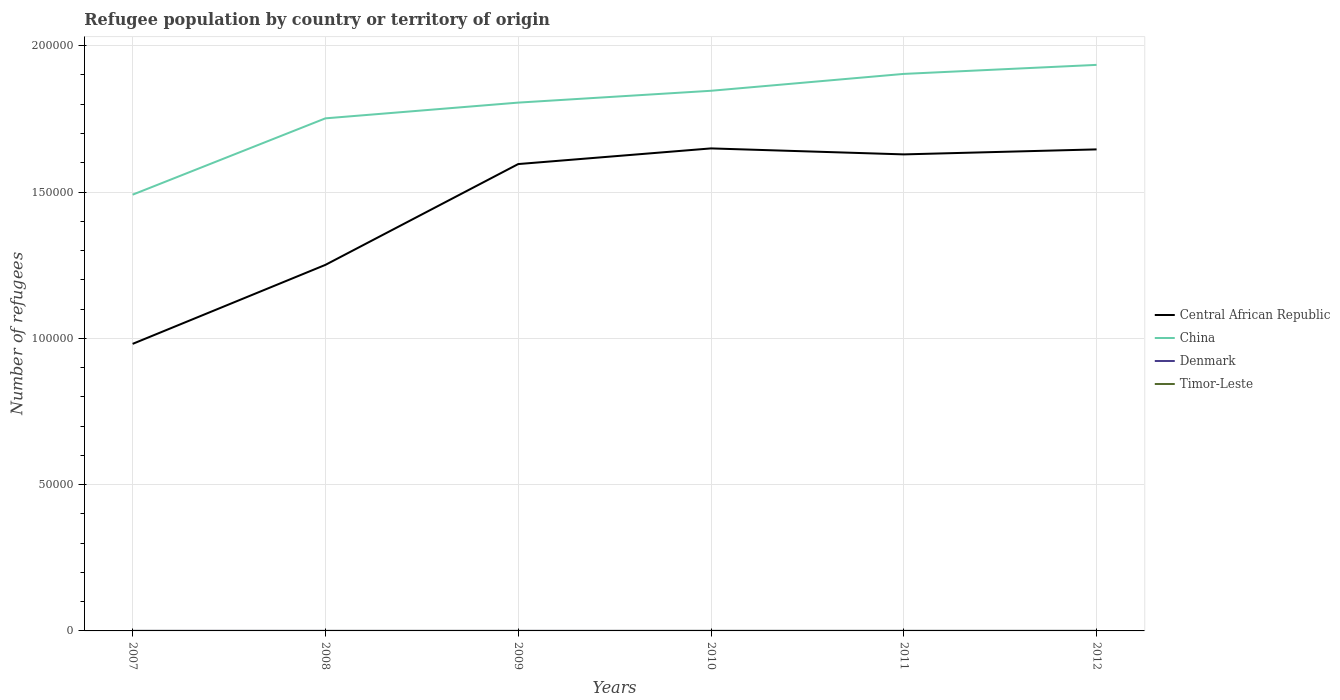How many different coloured lines are there?
Provide a succinct answer. 4. Is the number of lines equal to the number of legend labels?
Provide a succinct answer. Yes. Across all years, what is the maximum number of refugees in China?
Your answer should be very brief. 1.49e+05. In which year was the number of refugees in Central African Republic maximum?
Provide a short and direct response. 2007. What is the total number of refugees in Central African Republic in the graph?
Offer a very short reply. -5014. What is the difference between the highest and the second highest number of refugees in Timor-Leste?
Offer a terse response. 3. How many lines are there?
Provide a succinct answer. 4. How many years are there in the graph?
Your response must be concise. 6. What is the difference between two consecutive major ticks on the Y-axis?
Your response must be concise. 5.00e+04. Are the values on the major ticks of Y-axis written in scientific E-notation?
Your response must be concise. No. Where does the legend appear in the graph?
Ensure brevity in your answer.  Center right. What is the title of the graph?
Offer a terse response. Refugee population by country or territory of origin. What is the label or title of the Y-axis?
Offer a terse response. Number of refugees. What is the Number of refugees of Central African Republic in 2007?
Provide a succinct answer. 9.81e+04. What is the Number of refugees in China in 2007?
Ensure brevity in your answer.  1.49e+05. What is the Number of refugees of Timor-Leste in 2007?
Offer a terse response. 6. What is the Number of refugees in Central African Republic in 2008?
Ensure brevity in your answer.  1.25e+05. What is the Number of refugees of China in 2008?
Provide a short and direct response. 1.75e+05. What is the Number of refugees of Central African Republic in 2009?
Provide a short and direct response. 1.60e+05. What is the Number of refugees in China in 2009?
Provide a short and direct response. 1.81e+05. What is the Number of refugees of Central African Republic in 2010?
Ensure brevity in your answer.  1.65e+05. What is the Number of refugees in China in 2010?
Keep it short and to the point. 1.85e+05. What is the Number of refugees in Timor-Leste in 2010?
Your response must be concise. 8. What is the Number of refugees in Central African Republic in 2011?
Your response must be concise. 1.63e+05. What is the Number of refugees of China in 2011?
Keep it short and to the point. 1.90e+05. What is the Number of refugees of Timor-Leste in 2011?
Your answer should be very brief. 8. What is the Number of refugees in Central African Republic in 2012?
Make the answer very short. 1.65e+05. What is the Number of refugees in China in 2012?
Your answer should be compact. 1.93e+05. What is the Number of refugees in Denmark in 2012?
Give a very brief answer. 9. What is the Number of refugees in Timor-Leste in 2012?
Offer a very short reply. 9. Across all years, what is the maximum Number of refugees in Central African Republic?
Give a very brief answer. 1.65e+05. Across all years, what is the maximum Number of refugees of China?
Your answer should be compact. 1.93e+05. Across all years, what is the maximum Number of refugees in Denmark?
Provide a short and direct response. 14. Across all years, what is the minimum Number of refugees of Central African Republic?
Your response must be concise. 9.81e+04. Across all years, what is the minimum Number of refugees of China?
Your answer should be compact. 1.49e+05. Across all years, what is the minimum Number of refugees in Denmark?
Provide a succinct answer. 9. Across all years, what is the minimum Number of refugees of Timor-Leste?
Your answer should be compact. 6. What is the total Number of refugees of Central African Republic in the graph?
Your response must be concise. 8.75e+05. What is the total Number of refugees in China in the graph?
Give a very brief answer. 1.07e+06. What is the total Number of refugees of Denmark in the graph?
Make the answer very short. 62. What is the difference between the Number of refugees in Central African Republic in 2007 and that in 2008?
Your answer should be very brief. -2.70e+04. What is the difference between the Number of refugees in China in 2007 and that in 2008?
Your response must be concise. -2.61e+04. What is the difference between the Number of refugees of Central African Republic in 2007 and that in 2009?
Your answer should be very brief. -6.14e+04. What is the difference between the Number of refugees in China in 2007 and that in 2009?
Your response must be concise. -3.15e+04. What is the difference between the Number of refugees in Timor-Leste in 2007 and that in 2009?
Provide a succinct answer. -1. What is the difference between the Number of refugees of Central African Republic in 2007 and that in 2010?
Your answer should be very brief. -6.68e+04. What is the difference between the Number of refugees in China in 2007 and that in 2010?
Offer a very short reply. -3.55e+04. What is the difference between the Number of refugees of Denmark in 2007 and that in 2010?
Offer a very short reply. 5. What is the difference between the Number of refugees of Central African Republic in 2007 and that in 2011?
Give a very brief answer. -6.48e+04. What is the difference between the Number of refugees of China in 2007 and that in 2011?
Your response must be concise. -4.13e+04. What is the difference between the Number of refugees of Denmark in 2007 and that in 2011?
Offer a terse response. 5. What is the difference between the Number of refugees in Central African Republic in 2007 and that in 2012?
Provide a short and direct response. -6.65e+04. What is the difference between the Number of refugees in China in 2007 and that in 2012?
Your answer should be compact. -4.44e+04. What is the difference between the Number of refugees in Central African Republic in 2008 and that in 2009?
Your answer should be compact. -3.44e+04. What is the difference between the Number of refugees of China in 2008 and that in 2009?
Provide a short and direct response. -5378. What is the difference between the Number of refugees of Central African Republic in 2008 and that in 2010?
Your response must be concise. -3.98e+04. What is the difference between the Number of refugees of China in 2008 and that in 2010?
Your answer should be very brief. -9422. What is the difference between the Number of refugees of Denmark in 2008 and that in 2010?
Give a very brief answer. 2. What is the difference between the Number of refugees of Central African Republic in 2008 and that in 2011?
Give a very brief answer. -3.78e+04. What is the difference between the Number of refugees in China in 2008 and that in 2011?
Your response must be concise. -1.52e+04. What is the difference between the Number of refugees of Timor-Leste in 2008 and that in 2011?
Offer a very short reply. -1. What is the difference between the Number of refugees of Central African Republic in 2008 and that in 2012?
Offer a terse response. -3.95e+04. What is the difference between the Number of refugees in China in 2008 and that in 2012?
Your answer should be very brief. -1.83e+04. What is the difference between the Number of refugees in Timor-Leste in 2008 and that in 2012?
Offer a very short reply. -2. What is the difference between the Number of refugees of Central African Republic in 2009 and that in 2010?
Offer a terse response. -5351. What is the difference between the Number of refugees in China in 2009 and that in 2010?
Provide a short and direct response. -4044. What is the difference between the Number of refugees of Denmark in 2009 and that in 2010?
Keep it short and to the point. 1. What is the difference between the Number of refugees in Timor-Leste in 2009 and that in 2010?
Your response must be concise. -1. What is the difference between the Number of refugees in Central African Republic in 2009 and that in 2011?
Ensure brevity in your answer.  -3308. What is the difference between the Number of refugees of China in 2009 and that in 2011?
Your answer should be compact. -9811. What is the difference between the Number of refugees of Timor-Leste in 2009 and that in 2011?
Your answer should be compact. -1. What is the difference between the Number of refugees of Central African Republic in 2009 and that in 2012?
Offer a terse response. -5014. What is the difference between the Number of refugees of China in 2009 and that in 2012?
Provide a short and direct response. -1.29e+04. What is the difference between the Number of refugees of Denmark in 2009 and that in 2012?
Your response must be concise. 1. What is the difference between the Number of refugees in Central African Republic in 2010 and that in 2011?
Provide a short and direct response. 2043. What is the difference between the Number of refugees in China in 2010 and that in 2011?
Provide a short and direct response. -5767. What is the difference between the Number of refugees in Denmark in 2010 and that in 2011?
Your response must be concise. 0. What is the difference between the Number of refugees of Central African Republic in 2010 and that in 2012?
Offer a terse response. 337. What is the difference between the Number of refugees in China in 2010 and that in 2012?
Your answer should be very brief. -8851. What is the difference between the Number of refugees of Timor-Leste in 2010 and that in 2012?
Keep it short and to the point. -1. What is the difference between the Number of refugees of Central African Republic in 2011 and that in 2012?
Give a very brief answer. -1706. What is the difference between the Number of refugees in China in 2011 and that in 2012?
Ensure brevity in your answer.  -3084. What is the difference between the Number of refugees in Timor-Leste in 2011 and that in 2012?
Offer a very short reply. -1. What is the difference between the Number of refugees in Central African Republic in 2007 and the Number of refugees in China in 2008?
Ensure brevity in your answer.  -7.71e+04. What is the difference between the Number of refugees in Central African Republic in 2007 and the Number of refugees in Denmark in 2008?
Offer a terse response. 9.81e+04. What is the difference between the Number of refugees in Central African Republic in 2007 and the Number of refugees in Timor-Leste in 2008?
Ensure brevity in your answer.  9.81e+04. What is the difference between the Number of refugees in China in 2007 and the Number of refugees in Denmark in 2008?
Offer a very short reply. 1.49e+05. What is the difference between the Number of refugees of China in 2007 and the Number of refugees of Timor-Leste in 2008?
Your answer should be very brief. 1.49e+05. What is the difference between the Number of refugees in Denmark in 2007 and the Number of refugees in Timor-Leste in 2008?
Offer a very short reply. 7. What is the difference between the Number of refugees in Central African Republic in 2007 and the Number of refugees in China in 2009?
Keep it short and to the point. -8.25e+04. What is the difference between the Number of refugees of Central African Republic in 2007 and the Number of refugees of Denmark in 2009?
Ensure brevity in your answer.  9.81e+04. What is the difference between the Number of refugees of Central African Republic in 2007 and the Number of refugees of Timor-Leste in 2009?
Provide a short and direct response. 9.81e+04. What is the difference between the Number of refugees in China in 2007 and the Number of refugees in Denmark in 2009?
Keep it short and to the point. 1.49e+05. What is the difference between the Number of refugees in China in 2007 and the Number of refugees in Timor-Leste in 2009?
Offer a very short reply. 1.49e+05. What is the difference between the Number of refugees in Central African Republic in 2007 and the Number of refugees in China in 2010?
Provide a succinct answer. -8.65e+04. What is the difference between the Number of refugees of Central African Republic in 2007 and the Number of refugees of Denmark in 2010?
Give a very brief answer. 9.81e+04. What is the difference between the Number of refugees in Central African Republic in 2007 and the Number of refugees in Timor-Leste in 2010?
Provide a short and direct response. 9.81e+04. What is the difference between the Number of refugees of China in 2007 and the Number of refugees of Denmark in 2010?
Offer a very short reply. 1.49e+05. What is the difference between the Number of refugees of China in 2007 and the Number of refugees of Timor-Leste in 2010?
Offer a very short reply. 1.49e+05. What is the difference between the Number of refugees in Denmark in 2007 and the Number of refugees in Timor-Leste in 2010?
Ensure brevity in your answer.  6. What is the difference between the Number of refugees in Central African Republic in 2007 and the Number of refugees in China in 2011?
Provide a short and direct response. -9.23e+04. What is the difference between the Number of refugees of Central African Republic in 2007 and the Number of refugees of Denmark in 2011?
Provide a short and direct response. 9.81e+04. What is the difference between the Number of refugees of Central African Republic in 2007 and the Number of refugees of Timor-Leste in 2011?
Keep it short and to the point. 9.81e+04. What is the difference between the Number of refugees in China in 2007 and the Number of refugees in Denmark in 2011?
Your answer should be very brief. 1.49e+05. What is the difference between the Number of refugees of China in 2007 and the Number of refugees of Timor-Leste in 2011?
Ensure brevity in your answer.  1.49e+05. What is the difference between the Number of refugees in Denmark in 2007 and the Number of refugees in Timor-Leste in 2011?
Provide a succinct answer. 6. What is the difference between the Number of refugees in Central African Republic in 2007 and the Number of refugees in China in 2012?
Provide a succinct answer. -9.53e+04. What is the difference between the Number of refugees in Central African Republic in 2007 and the Number of refugees in Denmark in 2012?
Provide a short and direct response. 9.81e+04. What is the difference between the Number of refugees of Central African Republic in 2007 and the Number of refugees of Timor-Leste in 2012?
Offer a terse response. 9.81e+04. What is the difference between the Number of refugees of China in 2007 and the Number of refugees of Denmark in 2012?
Ensure brevity in your answer.  1.49e+05. What is the difference between the Number of refugees of China in 2007 and the Number of refugees of Timor-Leste in 2012?
Offer a very short reply. 1.49e+05. What is the difference between the Number of refugees in Central African Republic in 2008 and the Number of refugees in China in 2009?
Keep it short and to the point. -5.55e+04. What is the difference between the Number of refugees in Central African Republic in 2008 and the Number of refugees in Denmark in 2009?
Provide a succinct answer. 1.25e+05. What is the difference between the Number of refugees in Central African Republic in 2008 and the Number of refugees in Timor-Leste in 2009?
Keep it short and to the point. 1.25e+05. What is the difference between the Number of refugees of China in 2008 and the Number of refugees of Denmark in 2009?
Offer a terse response. 1.75e+05. What is the difference between the Number of refugees of China in 2008 and the Number of refugees of Timor-Leste in 2009?
Ensure brevity in your answer.  1.75e+05. What is the difference between the Number of refugees of Denmark in 2008 and the Number of refugees of Timor-Leste in 2009?
Your answer should be compact. 4. What is the difference between the Number of refugees in Central African Republic in 2008 and the Number of refugees in China in 2010?
Make the answer very short. -5.95e+04. What is the difference between the Number of refugees in Central African Republic in 2008 and the Number of refugees in Denmark in 2010?
Keep it short and to the point. 1.25e+05. What is the difference between the Number of refugees in Central African Republic in 2008 and the Number of refugees in Timor-Leste in 2010?
Provide a short and direct response. 1.25e+05. What is the difference between the Number of refugees of China in 2008 and the Number of refugees of Denmark in 2010?
Offer a very short reply. 1.75e+05. What is the difference between the Number of refugees of China in 2008 and the Number of refugees of Timor-Leste in 2010?
Provide a short and direct response. 1.75e+05. What is the difference between the Number of refugees in Central African Republic in 2008 and the Number of refugees in China in 2011?
Offer a terse response. -6.53e+04. What is the difference between the Number of refugees of Central African Republic in 2008 and the Number of refugees of Denmark in 2011?
Make the answer very short. 1.25e+05. What is the difference between the Number of refugees in Central African Republic in 2008 and the Number of refugees in Timor-Leste in 2011?
Your response must be concise. 1.25e+05. What is the difference between the Number of refugees in China in 2008 and the Number of refugees in Denmark in 2011?
Keep it short and to the point. 1.75e+05. What is the difference between the Number of refugees of China in 2008 and the Number of refugees of Timor-Leste in 2011?
Your answer should be compact. 1.75e+05. What is the difference between the Number of refugees in Denmark in 2008 and the Number of refugees in Timor-Leste in 2011?
Give a very brief answer. 3. What is the difference between the Number of refugees of Central African Republic in 2008 and the Number of refugees of China in 2012?
Ensure brevity in your answer.  -6.83e+04. What is the difference between the Number of refugees of Central African Republic in 2008 and the Number of refugees of Denmark in 2012?
Provide a succinct answer. 1.25e+05. What is the difference between the Number of refugees in Central African Republic in 2008 and the Number of refugees in Timor-Leste in 2012?
Ensure brevity in your answer.  1.25e+05. What is the difference between the Number of refugees of China in 2008 and the Number of refugees of Denmark in 2012?
Your answer should be compact. 1.75e+05. What is the difference between the Number of refugees in China in 2008 and the Number of refugees in Timor-Leste in 2012?
Give a very brief answer. 1.75e+05. What is the difference between the Number of refugees in Central African Republic in 2009 and the Number of refugees in China in 2010?
Provide a succinct answer. -2.50e+04. What is the difference between the Number of refugees of Central African Republic in 2009 and the Number of refugees of Denmark in 2010?
Your answer should be compact. 1.60e+05. What is the difference between the Number of refugees in Central African Republic in 2009 and the Number of refugees in Timor-Leste in 2010?
Make the answer very short. 1.60e+05. What is the difference between the Number of refugees of China in 2009 and the Number of refugees of Denmark in 2010?
Offer a very short reply. 1.81e+05. What is the difference between the Number of refugees in China in 2009 and the Number of refugees in Timor-Leste in 2010?
Ensure brevity in your answer.  1.81e+05. What is the difference between the Number of refugees in Denmark in 2009 and the Number of refugees in Timor-Leste in 2010?
Provide a short and direct response. 2. What is the difference between the Number of refugees of Central African Republic in 2009 and the Number of refugees of China in 2011?
Your answer should be very brief. -3.08e+04. What is the difference between the Number of refugees of Central African Republic in 2009 and the Number of refugees of Denmark in 2011?
Keep it short and to the point. 1.60e+05. What is the difference between the Number of refugees of Central African Republic in 2009 and the Number of refugees of Timor-Leste in 2011?
Provide a short and direct response. 1.60e+05. What is the difference between the Number of refugees of China in 2009 and the Number of refugees of Denmark in 2011?
Your response must be concise. 1.81e+05. What is the difference between the Number of refugees of China in 2009 and the Number of refugees of Timor-Leste in 2011?
Provide a short and direct response. 1.81e+05. What is the difference between the Number of refugees in Central African Republic in 2009 and the Number of refugees in China in 2012?
Keep it short and to the point. -3.39e+04. What is the difference between the Number of refugees of Central African Republic in 2009 and the Number of refugees of Denmark in 2012?
Your answer should be compact. 1.60e+05. What is the difference between the Number of refugees in Central African Republic in 2009 and the Number of refugees in Timor-Leste in 2012?
Give a very brief answer. 1.60e+05. What is the difference between the Number of refugees of China in 2009 and the Number of refugees of Denmark in 2012?
Offer a terse response. 1.81e+05. What is the difference between the Number of refugees of China in 2009 and the Number of refugees of Timor-Leste in 2012?
Give a very brief answer. 1.81e+05. What is the difference between the Number of refugees in Denmark in 2009 and the Number of refugees in Timor-Leste in 2012?
Give a very brief answer. 1. What is the difference between the Number of refugees of Central African Republic in 2010 and the Number of refugees of China in 2011?
Offer a terse response. -2.55e+04. What is the difference between the Number of refugees of Central African Republic in 2010 and the Number of refugees of Denmark in 2011?
Provide a succinct answer. 1.65e+05. What is the difference between the Number of refugees in Central African Republic in 2010 and the Number of refugees in Timor-Leste in 2011?
Make the answer very short. 1.65e+05. What is the difference between the Number of refugees of China in 2010 and the Number of refugees of Denmark in 2011?
Offer a terse response. 1.85e+05. What is the difference between the Number of refugees of China in 2010 and the Number of refugees of Timor-Leste in 2011?
Give a very brief answer. 1.85e+05. What is the difference between the Number of refugees of Central African Republic in 2010 and the Number of refugees of China in 2012?
Provide a short and direct response. -2.85e+04. What is the difference between the Number of refugees in Central African Republic in 2010 and the Number of refugees in Denmark in 2012?
Offer a terse response. 1.65e+05. What is the difference between the Number of refugees of Central African Republic in 2010 and the Number of refugees of Timor-Leste in 2012?
Your answer should be very brief. 1.65e+05. What is the difference between the Number of refugees of China in 2010 and the Number of refugees of Denmark in 2012?
Make the answer very short. 1.85e+05. What is the difference between the Number of refugees of China in 2010 and the Number of refugees of Timor-Leste in 2012?
Offer a very short reply. 1.85e+05. What is the difference between the Number of refugees of Denmark in 2010 and the Number of refugees of Timor-Leste in 2012?
Make the answer very short. 0. What is the difference between the Number of refugees of Central African Republic in 2011 and the Number of refugees of China in 2012?
Ensure brevity in your answer.  -3.06e+04. What is the difference between the Number of refugees in Central African Republic in 2011 and the Number of refugees in Denmark in 2012?
Ensure brevity in your answer.  1.63e+05. What is the difference between the Number of refugees in Central African Republic in 2011 and the Number of refugees in Timor-Leste in 2012?
Keep it short and to the point. 1.63e+05. What is the difference between the Number of refugees of China in 2011 and the Number of refugees of Denmark in 2012?
Keep it short and to the point. 1.90e+05. What is the difference between the Number of refugees in China in 2011 and the Number of refugees in Timor-Leste in 2012?
Ensure brevity in your answer.  1.90e+05. What is the difference between the Number of refugees in Denmark in 2011 and the Number of refugees in Timor-Leste in 2012?
Your answer should be compact. 0. What is the average Number of refugees of Central African Republic per year?
Make the answer very short. 1.46e+05. What is the average Number of refugees of China per year?
Your answer should be very brief. 1.79e+05. What is the average Number of refugees of Denmark per year?
Provide a short and direct response. 10.33. What is the average Number of refugees of Timor-Leste per year?
Provide a short and direct response. 7.5. In the year 2007, what is the difference between the Number of refugees in Central African Republic and Number of refugees in China?
Your answer should be compact. -5.10e+04. In the year 2007, what is the difference between the Number of refugees in Central African Republic and Number of refugees in Denmark?
Provide a succinct answer. 9.81e+04. In the year 2007, what is the difference between the Number of refugees of Central African Republic and Number of refugees of Timor-Leste?
Offer a terse response. 9.81e+04. In the year 2007, what is the difference between the Number of refugees of China and Number of refugees of Denmark?
Offer a terse response. 1.49e+05. In the year 2007, what is the difference between the Number of refugees in China and Number of refugees in Timor-Leste?
Provide a succinct answer. 1.49e+05. In the year 2007, what is the difference between the Number of refugees of Denmark and Number of refugees of Timor-Leste?
Your answer should be compact. 8. In the year 2008, what is the difference between the Number of refugees of Central African Republic and Number of refugees of China?
Offer a very short reply. -5.01e+04. In the year 2008, what is the difference between the Number of refugees of Central African Republic and Number of refugees of Denmark?
Make the answer very short. 1.25e+05. In the year 2008, what is the difference between the Number of refugees of Central African Republic and Number of refugees of Timor-Leste?
Give a very brief answer. 1.25e+05. In the year 2008, what is the difference between the Number of refugees of China and Number of refugees of Denmark?
Offer a terse response. 1.75e+05. In the year 2008, what is the difference between the Number of refugees of China and Number of refugees of Timor-Leste?
Your answer should be compact. 1.75e+05. In the year 2009, what is the difference between the Number of refugees of Central African Republic and Number of refugees of China?
Keep it short and to the point. -2.10e+04. In the year 2009, what is the difference between the Number of refugees of Central African Republic and Number of refugees of Denmark?
Make the answer very short. 1.60e+05. In the year 2009, what is the difference between the Number of refugees of Central African Republic and Number of refugees of Timor-Leste?
Your answer should be very brief. 1.60e+05. In the year 2009, what is the difference between the Number of refugees of China and Number of refugees of Denmark?
Keep it short and to the point. 1.81e+05. In the year 2009, what is the difference between the Number of refugees in China and Number of refugees in Timor-Leste?
Your answer should be compact. 1.81e+05. In the year 2010, what is the difference between the Number of refugees of Central African Republic and Number of refugees of China?
Give a very brief answer. -1.97e+04. In the year 2010, what is the difference between the Number of refugees of Central African Republic and Number of refugees of Denmark?
Keep it short and to the point. 1.65e+05. In the year 2010, what is the difference between the Number of refugees of Central African Republic and Number of refugees of Timor-Leste?
Your answer should be compact. 1.65e+05. In the year 2010, what is the difference between the Number of refugees of China and Number of refugees of Denmark?
Provide a succinct answer. 1.85e+05. In the year 2010, what is the difference between the Number of refugees of China and Number of refugees of Timor-Leste?
Provide a succinct answer. 1.85e+05. In the year 2010, what is the difference between the Number of refugees in Denmark and Number of refugees in Timor-Leste?
Ensure brevity in your answer.  1. In the year 2011, what is the difference between the Number of refugees of Central African Republic and Number of refugees of China?
Keep it short and to the point. -2.75e+04. In the year 2011, what is the difference between the Number of refugees of Central African Republic and Number of refugees of Denmark?
Your answer should be very brief. 1.63e+05. In the year 2011, what is the difference between the Number of refugees in Central African Republic and Number of refugees in Timor-Leste?
Give a very brief answer. 1.63e+05. In the year 2011, what is the difference between the Number of refugees of China and Number of refugees of Denmark?
Offer a very short reply. 1.90e+05. In the year 2011, what is the difference between the Number of refugees in China and Number of refugees in Timor-Leste?
Offer a very short reply. 1.90e+05. In the year 2011, what is the difference between the Number of refugees of Denmark and Number of refugees of Timor-Leste?
Provide a short and direct response. 1. In the year 2012, what is the difference between the Number of refugees of Central African Republic and Number of refugees of China?
Your response must be concise. -2.89e+04. In the year 2012, what is the difference between the Number of refugees in Central African Republic and Number of refugees in Denmark?
Give a very brief answer. 1.65e+05. In the year 2012, what is the difference between the Number of refugees in Central African Republic and Number of refugees in Timor-Leste?
Keep it short and to the point. 1.65e+05. In the year 2012, what is the difference between the Number of refugees in China and Number of refugees in Denmark?
Provide a short and direct response. 1.93e+05. In the year 2012, what is the difference between the Number of refugees in China and Number of refugees in Timor-Leste?
Your response must be concise. 1.93e+05. What is the ratio of the Number of refugees of Central African Republic in 2007 to that in 2008?
Offer a very short reply. 0.78. What is the ratio of the Number of refugees in China in 2007 to that in 2008?
Your answer should be very brief. 0.85. What is the ratio of the Number of refugees of Denmark in 2007 to that in 2008?
Offer a terse response. 1.27. What is the ratio of the Number of refugees in Timor-Leste in 2007 to that in 2008?
Ensure brevity in your answer.  0.86. What is the ratio of the Number of refugees in Central African Republic in 2007 to that in 2009?
Your answer should be compact. 0.61. What is the ratio of the Number of refugees of China in 2007 to that in 2009?
Provide a succinct answer. 0.83. What is the ratio of the Number of refugees of Timor-Leste in 2007 to that in 2009?
Make the answer very short. 0.86. What is the ratio of the Number of refugees of Central African Republic in 2007 to that in 2010?
Offer a terse response. 0.59. What is the ratio of the Number of refugees of China in 2007 to that in 2010?
Offer a very short reply. 0.81. What is the ratio of the Number of refugees in Denmark in 2007 to that in 2010?
Provide a short and direct response. 1.56. What is the ratio of the Number of refugees in Central African Republic in 2007 to that in 2011?
Your response must be concise. 0.6. What is the ratio of the Number of refugees of China in 2007 to that in 2011?
Ensure brevity in your answer.  0.78. What is the ratio of the Number of refugees of Denmark in 2007 to that in 2011?
Your response must be concise. 1.56. What is the ratio of the Number of refugees of Central African Republic in 2007 to that in 2012?
Provide a succinct answer. 0.6. What is the ratio of the Number of refugees in China in 2007 to that in 2012?
Your response must be concise. 0.77. What is the ratio of the Number of refugees in Denmark in 2007 to that in 2012?
Ensure brevity in your answer.  1.56. What is the ratio of the Number of refugees of Timor-Leste in 2007 to that in 2012?
Your response must be concise. 0.67. What is the ratio of the Number of refugees in Central African Republic in 2008 to that in 2009?
Offer a terse response. 0.78. What is the ratio of the Number of refugees of China in 2008 to that in 2009?
Your answer should be very brief. 0.97. What is the ratio of the Number of refugees in Denmark in 2008 to that in 2009?
Offer a very short reply. 1.1. What is the ratio of the Number of refugees of Timor-Leste in 2008 to that in 2009?
Offer a terse response. 1. What is the ratio of the Number of refugees of Central African Republic in 2008 to that in 2010?
Your answer should be very brief. 0.76. What is the ratio of the Number of refugees of China in 2008 to that in 2010?
Your answer should be very brief. 0.95. What is the ratio of the Number of refugees in Denmark in 2008 to that in 2010?
Provide a short and direct response. 1.22. What is the ratio of the Number of refugees of Timor-Leste in 2008 to that in 2010?
Ensure brevity in your answer.  0.88. What is the ratio of the Number of refugees of Central African Republic in 2008 to that in 2011?
Offer a very short reply. 0.77. What is the ratio of the Number of refugees in China in 2008 to that in 2011?
Offer a terse response. 0.92. What is the ratio of the Number of refugees of Denmark in 2008 to that in 2011?
Give a very brief answer. 1.22. What is the ratio of the Number of refugees in Timor-Leste in 2008 to that in 2011?
Make the answer very short. 0.88. What is the ratio of the Number of refugees of Central African Republic in 2008 to that in 2012?
Offer a terse response. 0.76. What is the ratio of the Number of refugees of China in 2008 to that in 2012?
Your answer should be compact. 0.91. What is the ratio of the Number of refugees in Denmark in 2008 to that in 2012?
Make the answer very short. 1.22. What is the ratio of the Number of refugees of Central African Republic in 2009 to that in 2010?
Provide a succinct answer. 0.97. What is the ratio of the Number of refugees of China in 2009 to that in 2010?
Your response must be concise. 0.98. What is the ratio of the Number of refugees of Denmark in 2009 to that in 2010?
Make the answer very short. 1.11. What is the ratio of the Number of refugees in Timor-Leste in 2009 to that in 2010?
Your response must be concise. 0.88. What is the ratio of the Number of refugees in Central African Republic in 2009 to that in 2011?
Your answer should be very brief. 0.98. What is the ratio of the Number of refugees of China in 2009 to that in 2011?
Give a very brief answer. 0.95. What is the ratio of the Number of refugees of Central African Republic in 2009 to that in 2012?
Your answer should be very brief. 0.97. What is the ratio of the Number of refugees of China in 2009 to that in 2012?
Make the answer very short. 0.93. What is the ratio of the Number of refugees in Timor-Leste in 2009 to that in 2012?
Your response must be concise. 0.78. What is the ratio of the Number of refugees in Central African Republic in 2010 to that in 2011?
Your response must be concise. 1.01. What is the ratio of the Number of refugees of China in 2010 to that in 2011?
Your response must be concise. 0.97. What is the ratio of the Number of refugees of Denmark in 2010 to that in 2011?
Provide a succinct answer. 1. What is the ratio of the Number of refugees in Central African Republic in 2010 to that in 2012?
Give a very brief answer. 1. What is the ratio of the Number of refugees in China in 2010 to that in 2012?
Offer a terse response. 0.95. What is the ratio of the Number of refugees of Central African Republic in 2011 to that in 2012?
Offer a terse response. 0.99. What is the ratio of the Number of refugees of China in 2011 to that in 2012?
Make the answer very short. 0.98. What is the ratio of the Number of refugees of Denmark in 2011 to that in 2012?
Your response must be concise. 1. What is the ratio of the Number of refugees in Timor-Leste in 2011 to that in 2012?
Your answer should be very brief. 0.89. What is the difference between the highest and the second highest Number of refugees in Central African Republic?
Your answer should be very brief. 337. What is the difference between the highest and the second highest Number of refugees in China?
Give a very brief answer. 3084. What is the difference between the highest and the second highest Number of refugees of Denmark?
Provide a short and direct response. 3. What is the difference between the highest and the lowest Number of refugees of Central African Republic?
Your answer should be compact. 6.68e+04. What is the difference between the highest and the lowest Number of refugees in China?
Offer a terse response. 4.44e+04. What is the difference between the highest and the lowest Number of refugees of Timor-Leste?
Give a very brief answer. 3. 